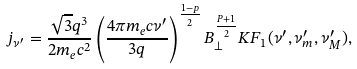Convert formula to latex. <formula><loc_0><loc_0><loc_500><loc_500>j _ { \nu ^ { \prime } } = \frac { \sqrt { 3 } q ^ { 3 } } { 2 m _ { e } c ^ { 2 } } \left ( \frac { 4 \pi m _ { e } c \nu ^ { \prime } } { 3 q } \right ) ^ { \frac { 1 - p } { 2 } } B _ { \bot } ^ { \frac { P + 1 } { 2 } } K F _ { 1 } ( \nu ^ { \prime } , \nu ^ { \prime } _ { m } , \nu ^ { \prime } _ { M } ) ,</formula> 